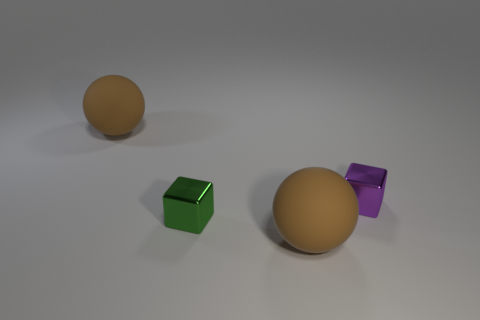Add 4 small green shiny blocks. How many objects exist? 8 Subtract 1 spheres. How many spheres are left? 1 Subtract all green cubes. How many cubes are left? 1 Add 2 rubber balls. How many rubber balls exist? 4 Subtract 0 blue cylinders. How many objects are left? 4 Subtract all blue spheres. Subtract all red blocks. How many spheres are left? 2 Subtract all matte things. Subtract all small purple blocks. How many objects are left? 1 Add 2 spheres. How many spheres are left? 4 